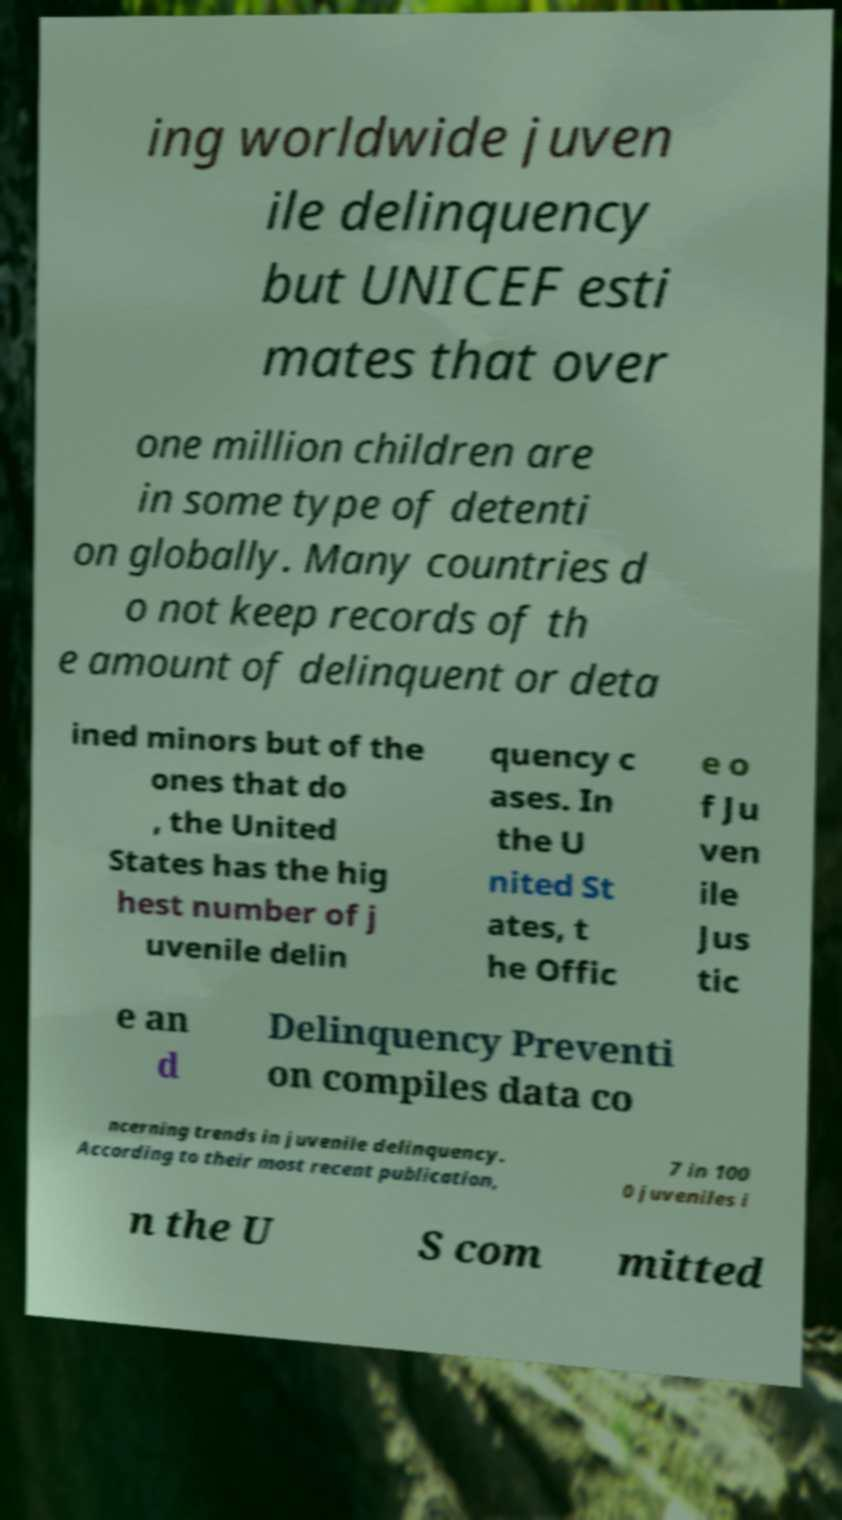Please read and relay the text visible in this image. What does it say? ing worldwide juven ile delinquency but UNICEF esti mates that over one million children are in some type of detenti on globally. Many countries d o not keep records of th e amount of delinquent or deta ined minors but of the ones that do , the United States has the hig hest number of j uvenile delin quency c ases. In the U nited St ates, t he Offic e o f Ju ven ile Jus tic e an d Delinquency Preventi on compiles data co ncerning trends in juvenile delinquency. According to their most recent publication, 7 in 100 0 juveniles i n the U S com mitted 